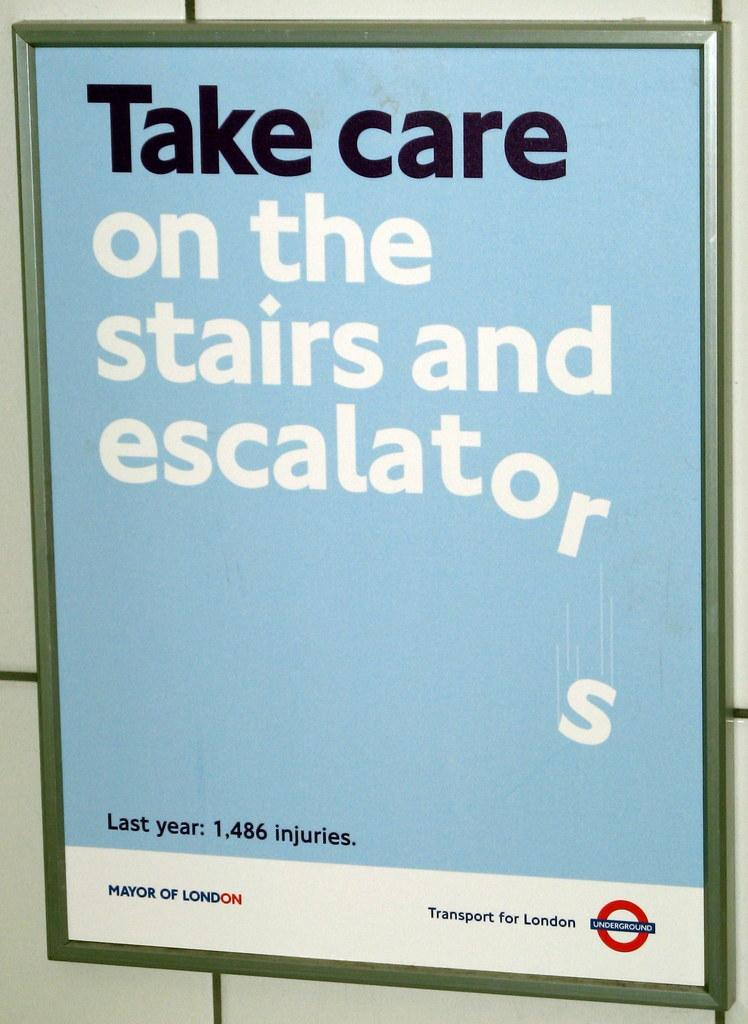Provide a one-sentence caption for the provided image. a sign that says to take care on stairs. 